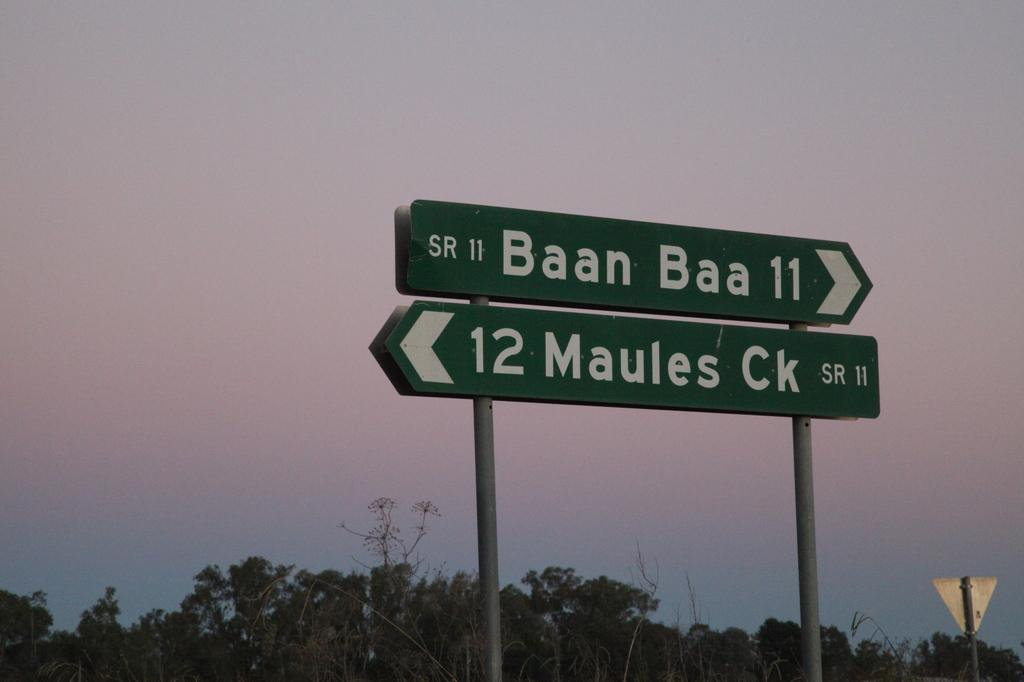Provide a one-sentence caption for the provided image. a baan baa 11 sign with 12 maules ck under. 